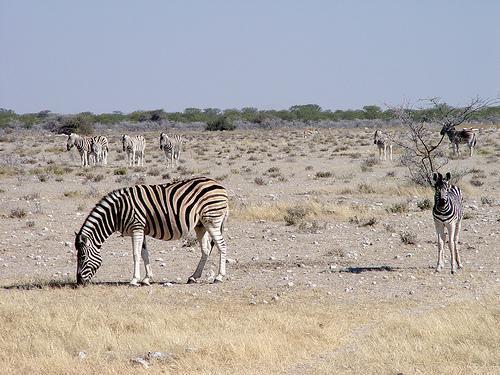How many zebras are grazing?
Give a very brief answer. 1. How many zebras are in the photo?
Give a very brief answer. 2. 